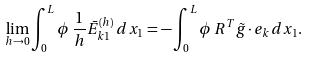<formula> <loc_0><loc_0><loc_500><loc_500>\lim _ { h \to 0 } \int _ { 0 } ^ { L } \phi \, \frac { 1 } { h } \bar { E } ^ { ( h ) } _ { k 1 } \, d x _ { 1 } = - \int _ { 0 } ^ { L } \phi \, R ^ { T } \tilde { g } { \, \cdot \, } e _ { k } \, d x _ { 1 } .</formula> 